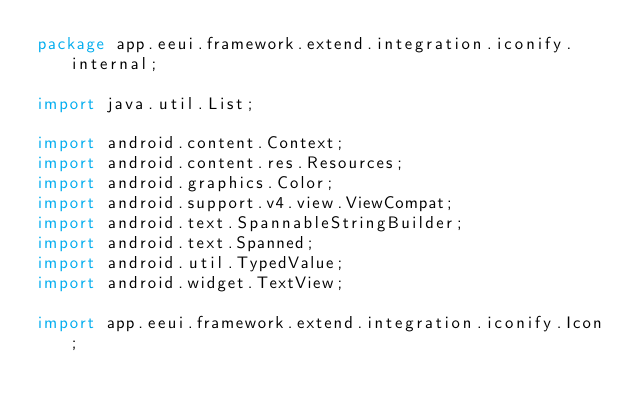<code> <loc_0><loc_0><loc_500><loc_500><_Java_>package app.eeui.framework.extend.integration.iconify.internal;

import java.util.List;

import android.content.Context;
import android.content.res.Resources;
import android.graphics.Color;
import android.support.v4.view.ViewCompat;
import android.text.SpannableStringBuilder;
import android.text.Spanned;
import android.util.TypedValue;
import android.widget.TextView;

import app.eeui.framework.extend.integration.iconify.Icon;</code> 